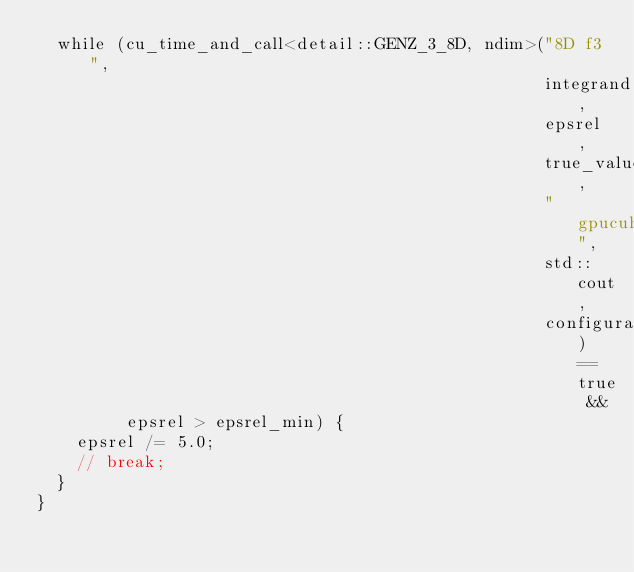Convert code to text. <code><loc_0><loc_0><loc_500><loc_500><_Cuda_>  while (cu_time_and_call<detail::GENZ_3_8D, ndim>("8D f3",
                                                   integrand,
                                                   epsrel,
                                                   true_value,
                                                   "gpucuhre",
                                                   std::cout,
                                                   configuration) == true &&
         epsrel > epsrel_min) {
    epsrel /= 5.0;
    // break;
  }
}
</code> 